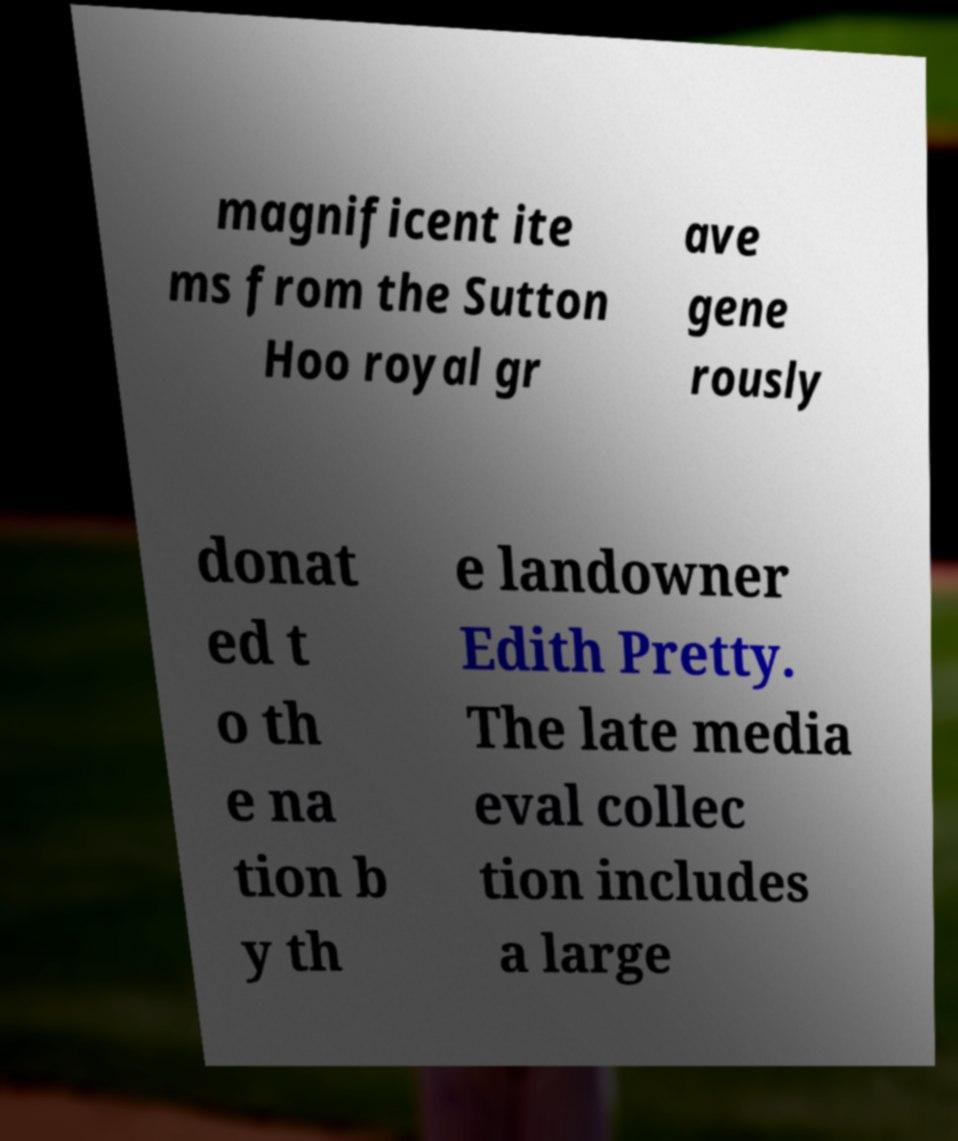There's text embedded in this image that I need extracted. Can you transcribe it verbatim? magnificent ite ms from the Sutton Hoo royal gr ave gene rously donat ed t o th e na tion b y th e landowner Edith Pretty. The late media eval collec tion includes a large 